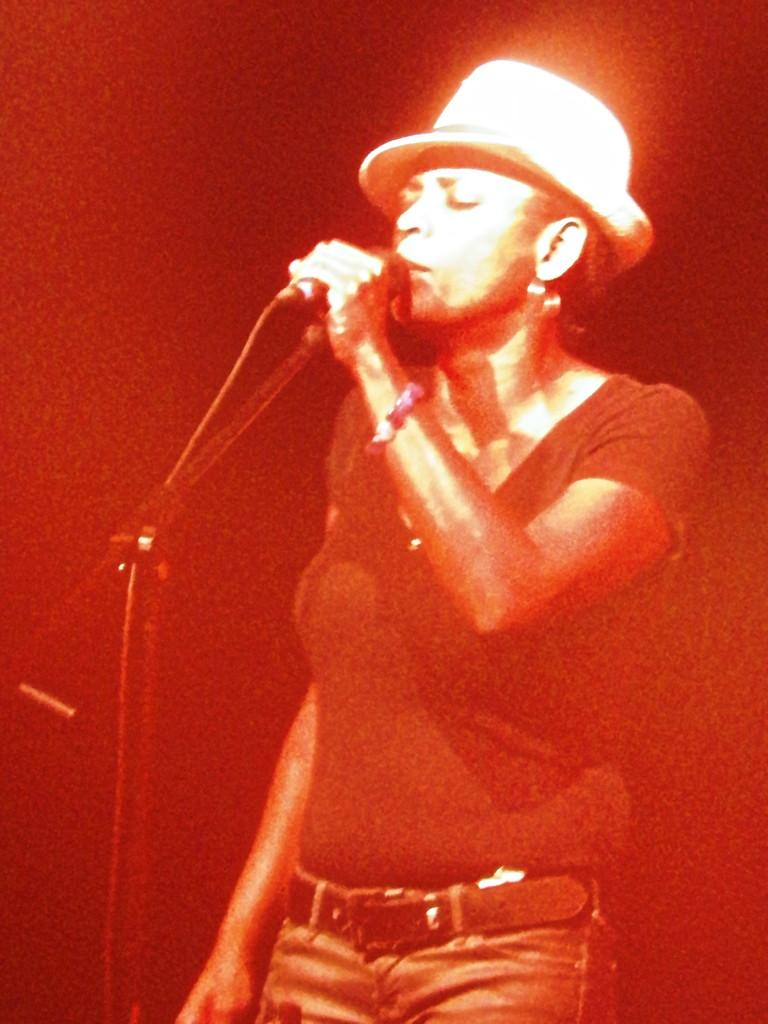Who is the main subject in the image? There is a girl in the image. Where is the girl located in the image? The girl is in the center of the image. What is the girl holding in her hand? The girl is holding a mic in her hand. What type of structure is visible behind the girl in the image? There is no structure visible behind the girl in the image; only the girl and the mic are present. Is the girl performing on a stage in the image? The provided facts do not mention a stage, so it cannot be confirmed from the image. 